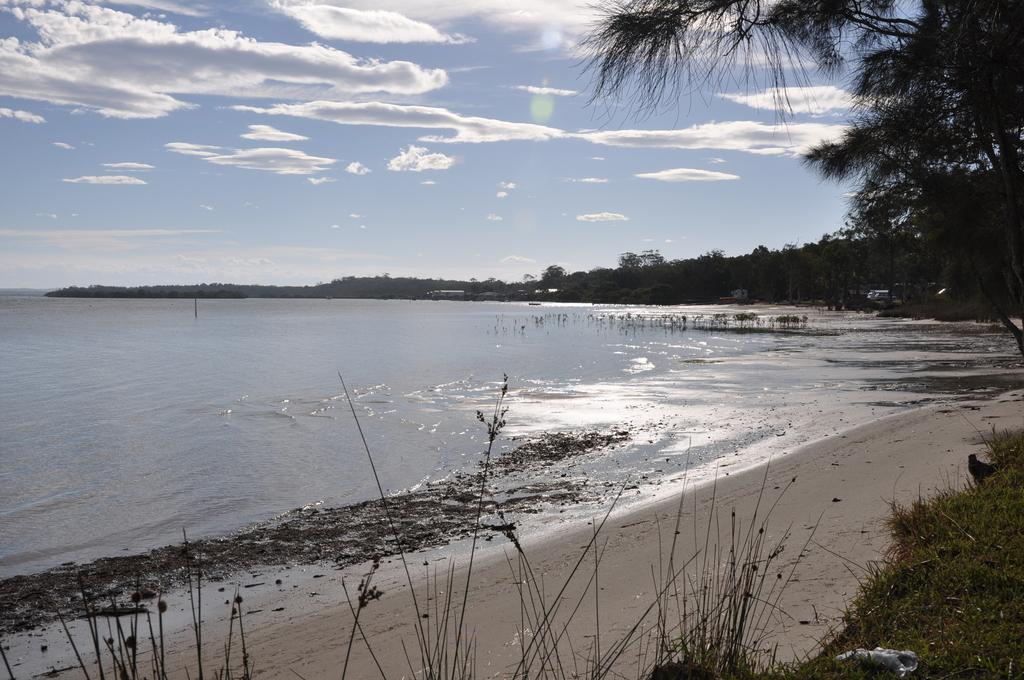Describe this image in one or two sentences. In the center of the image we can see a sea. On the right there are trees. In the background there are hills and sky. At the bottom there is grass. 